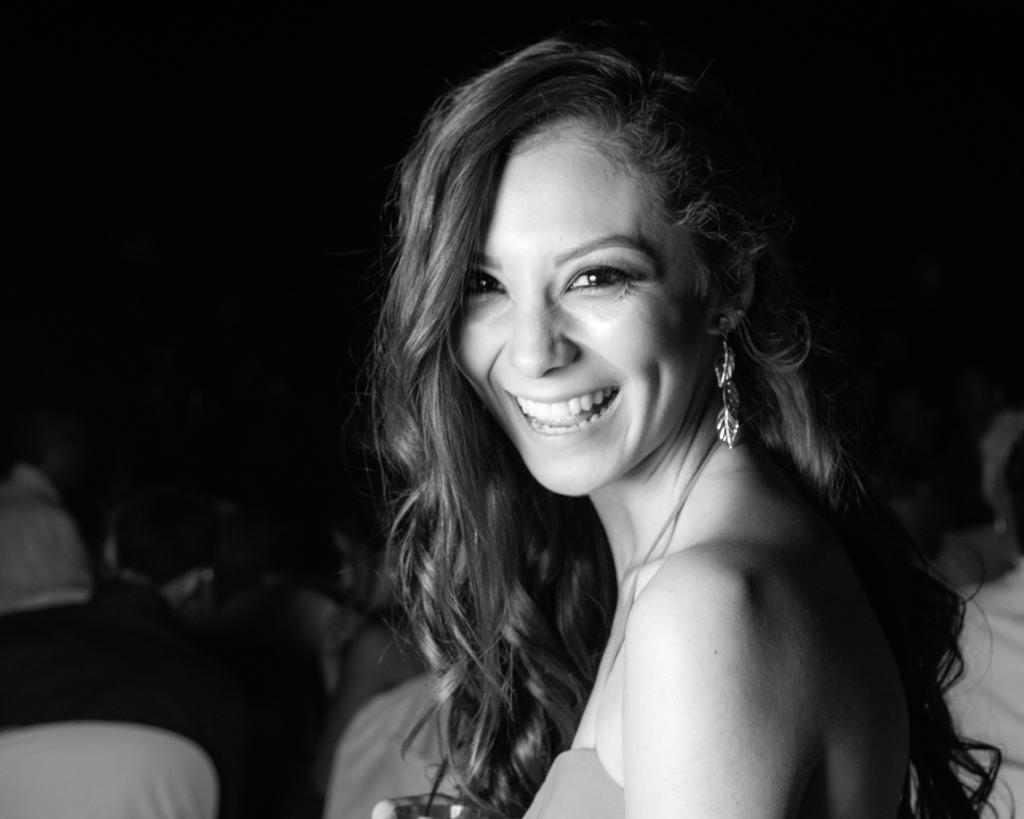Please provide a concise description of this image. It is a black and white image there is a woman, she is smiling and the background of the woman is dark. She is wearing a leaf design earrings. 